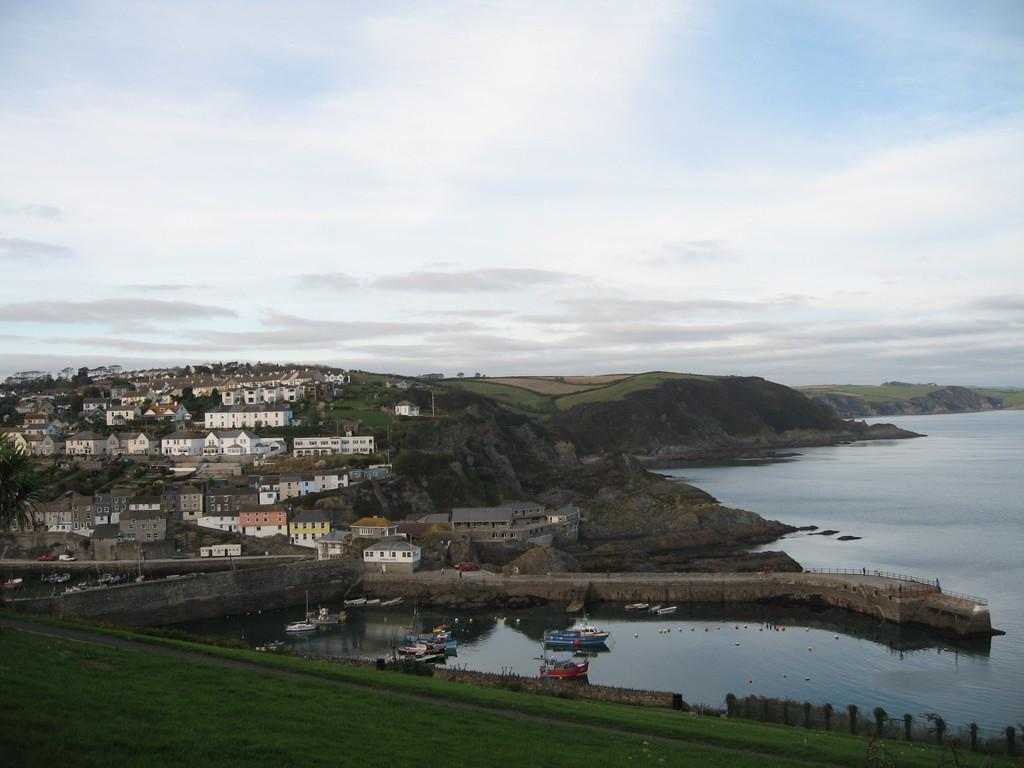What type of structures can be seen in the image? There are houses in the image. What other natural elements are present in the image? There are trees in the image. What body of water is visible in the image? There are boats on the ocean in the image. What part of the natural environment is visible in the image? The sky is visible in the image. What type of hair can be seen on the boats in the image? There are no boats with hair present in the image; the boats are inanimate objects. 